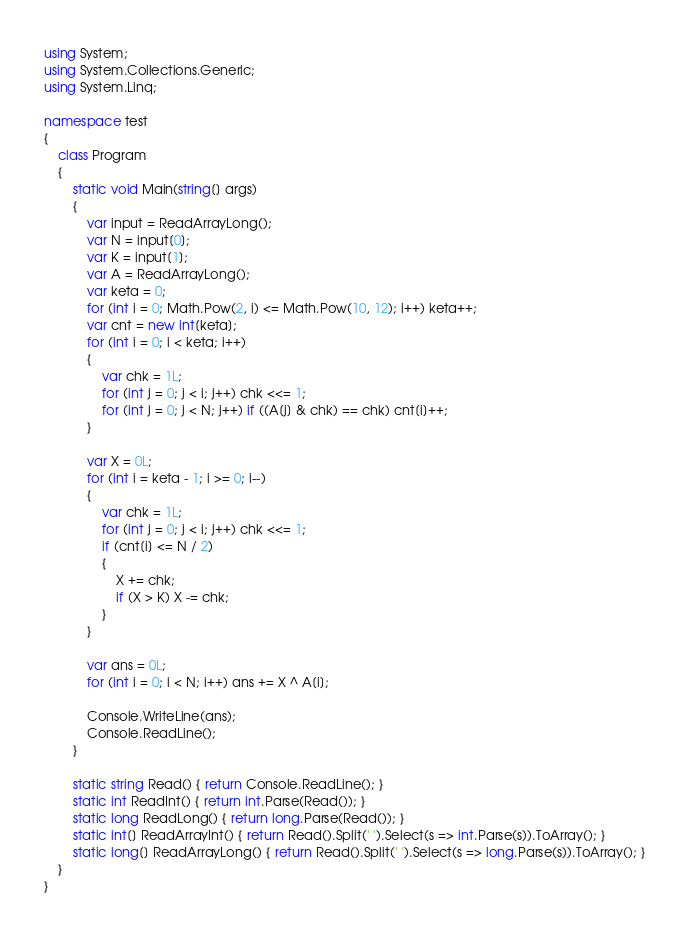<code> <loc_0><loc_0><loc_500><loc_500><_C#_>using System;
using System.Collections.Generic;
using System.Linq;

namespace test
{
    class Program
    {
        static void Main(string[] args)
        {
            var input = ReadArrayLong();
            var N = input[0];
            var K = input[1];
            var A = ReadArrayLong();
            var keta = 0;
            for (int i = 0; Math.Pow(2, i) <= Math.Pow(10, 12); i++) keta++;
            var cnt = new int[keta];
            for (int i = 0; i < keta; i++)
            {
                var chk = 1L;
                for (int j = 0; j < i; j++) chk <<= 1;
                for (int j = 0; j < N; j++) if ((A[j] & chk) == chk) cnt[i]++;
            }
            
            var X = 0L;
            for (int i = keta - 1; i >= 0; i--)
            {
                var chk = 1L;
                for (int j = 0; j < i; j++) chk <<= 1;
                if (cnt[i] <= N / 2)
                {
                    X += chk;
                    if (X > K) X -= chk;                    
                }
            }
            
            var ans = 0L;
            for (int i = 0; i < N; i++) ans += X ^ A[i];

            Console.WriteLine(ans);
            Console.ReadLine();
        }

        static string Read() { return Console.ReadLine(); }
        static int ReadInt() { return int.Parse(Read()); }
        static long ReadLong() { return long.Parse(Read()); }
        static int[] ReadArrayInt() { return Read().Split(' ').Select(s => int.Parse(s)).ToArray(); }
        static long[] ReadArrayLong() { return Read().Split(' ').Select(s => long.Parse(s)).ToArray(); }
    }
}</code> 